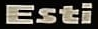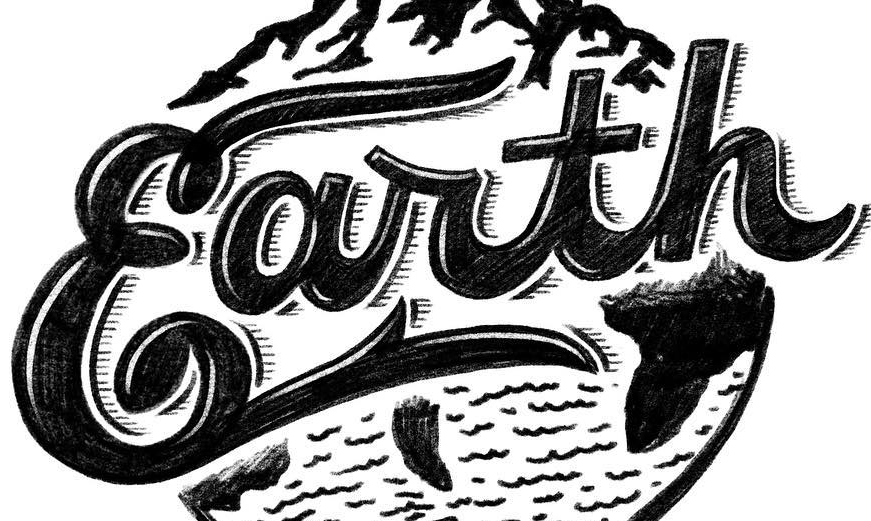What words can you see in these images in sequence, separated by a semicolon? Esti; Earth 